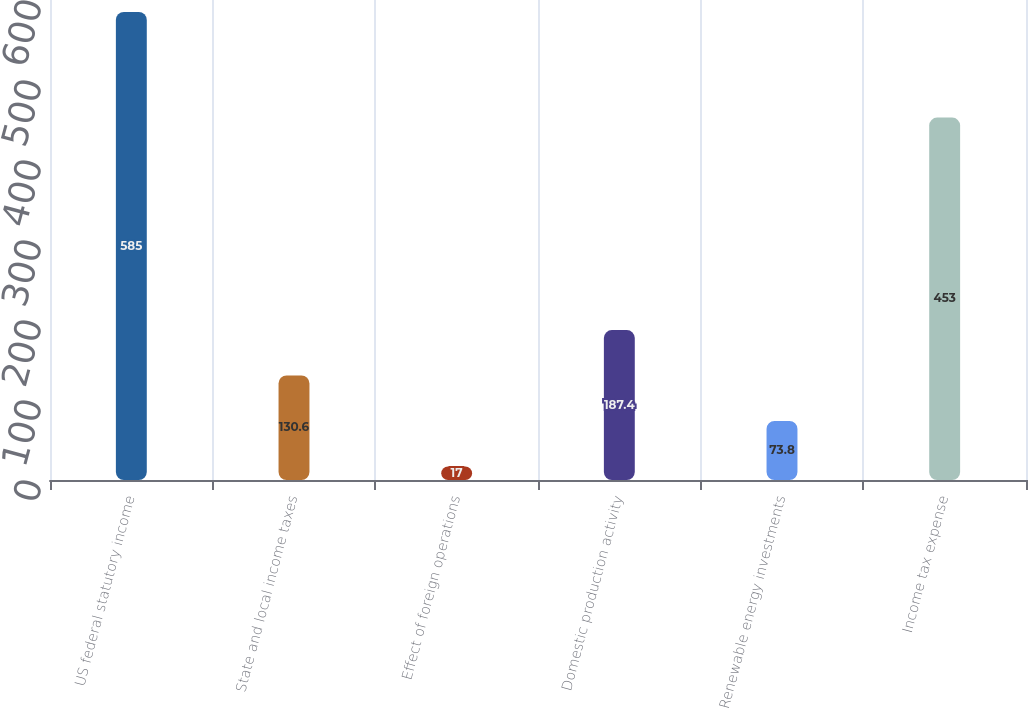<chart> <loc_0><loc_0><loc_500><loc_500><bar_chart><fcel>US federal statutory income<fcel>State and local income taxes<fcel>Effect of foreign operations<fcel>Domestic production activity<fcel>Renewable energy investments<fcel>Income tax expense<nl><fcel>585<fcel>130.6<fcel>17<fcel>187.4<fcel>73.8<fcel>453<nl></chart> 